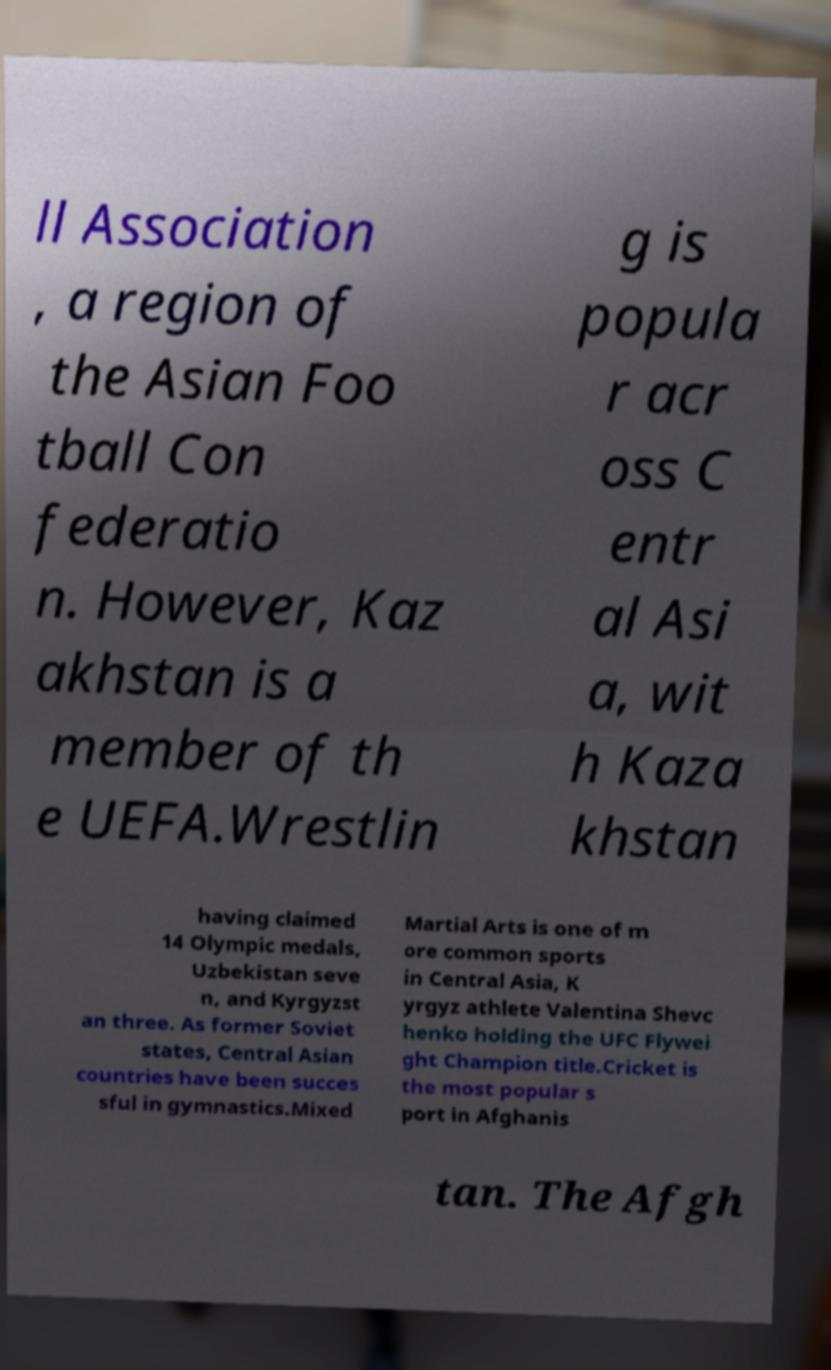What messages or text are displayed in this image? I need them in a readable, typed format. ll Association , a region of the Asian Foo tball Con federatio n. However, Kaz akhstan is a member of th e UEFA.Wrestlin g is popula r acr oss C entr al Asi a, wit h Kaza khstan having claimed 14 Olympic medals, Uzbekistan seve n, and Kyrgyzst an three. As former Soviet states, Central Asian countries have been succes sful in gymnastics.Mixed Martial Arts is one of m ore common sports in Central Asia, K yrgyz athlete Valentina Shevc henko holding the UFC Flywei ght Champion title.Cricket is the most popular s port in Afghanis tan. The Afgh 